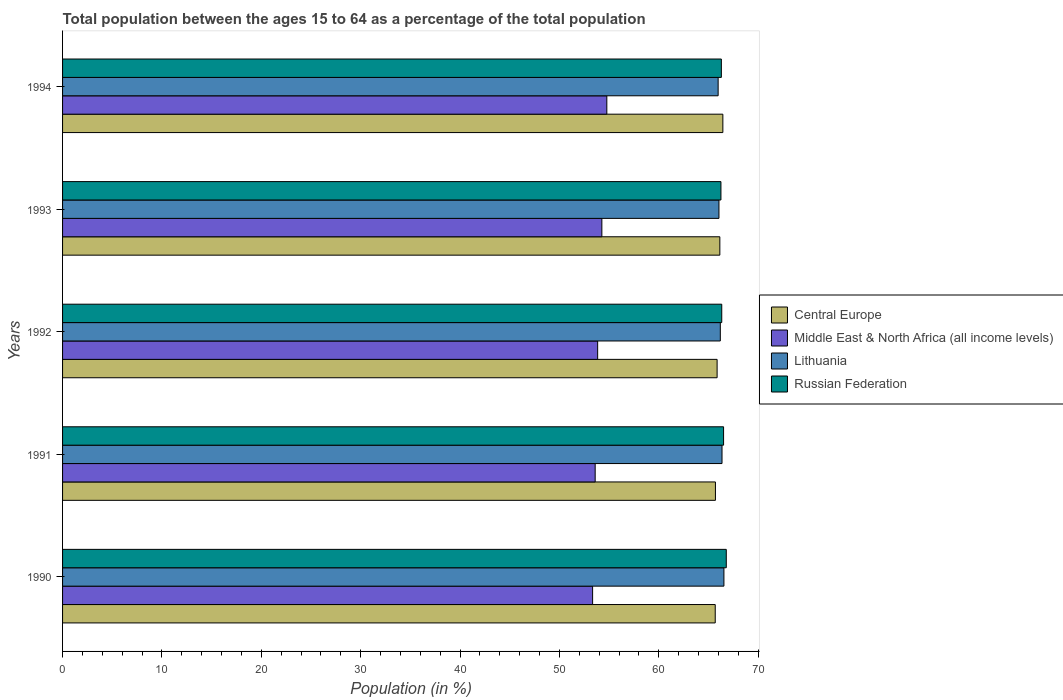How many groups of bars are there?
Give a very brief answer. 5. Are the number of bars per tick equal to the number of legend labels?
Your answer should be very brief. Yes. What is the label of the 2nd group of bars from the top?
Your answer should be compact. 1993. In how many cases, is the number of bars for a given year not equal to the number of legend labels?
Offer a very short reply. 0. What is the percentage of the population ages 15 to 64 in Middle East & North Africa (all income levels) in 1993?
Offer a terse response. 54.27. Across all years, what is the maximum percentage of the population ages 15 to 64 in Russian Federation?
Make the answer very short. 66.79. Across all years, what is the minimum percentage of the population ages 15 to 64 in Russian Federation?
Ensure brevity in your answer.  66.25. In which year was the percentage of the population ages 15 to 64 in Middle East & North Africa (all income levels) minimum?
Make the answer very short. 1990. What is the total percentage of the population ages 15 to 64 in Lithuania in the graph?
Ensure brevity in your answer.  331.14. What is the difference between the percentage of the population ages 15 to 64 in Lithuania in 1990 and that in 1993?
Your answer should be compact. 0.5. What is the difference between the percentage of the population ages 15 to 64 in Lithuania in 1990 and the percentage of the population ages 15 to 64 in Central Europe in 1992?
Your response must be concise. 0.69. What is the average percentage of the population ages 15 to 64 in Lithuania per year?
Keep it short and to the point. 66.23. In the year 1991, what is the difference between the percentage of the population ages 15 to 64 in Central Europe and percentage of the population ages 15 to 64 in Middle East & North Africa (all income levels)?
Your answer should be very brief. 12.1. In how many years, is the percentage of the population ages 15 to 64 in Russian Federation greater than 24 ?
Your answer should be very brief. 5. What is the ratio of the percentage of the population ages 15 to 64 in Middle East & North Africa (all income levels) in 1991 to that in 1993?
Ensure brevity in your answer.  0.99. Is the difference between the percentage of the population ages 15 to 64 in Central Europe in 1991 and 1992 greater than the difference between the percentage of the population ages 15 to 64 in Middle East & North Africa (all income levels) in 1991 and 1992?
Give a very brief answer. Yes. What is the difference between the highest and the second highest percentage of the population ages 15 to 64 in Russian Federation?
Your answer should be very brief. 0.27. What is the difference between the highest and the lowest percentage of the population ages 15 to 64 in Middle East & North Africa (all income levels)?
Your response must be concise. 1.43. Is it the case that in every year, the sum of the percentage of the population ages 15 to 64 in Lithuania and percentage of the population ages 15 to 64 in Russian Federation is greater than the sum of percentage of the population ages 15 to 64 in Central Europe and percentage of the population ages 15 to 64 in Middle East & North Africa (all income levels)?
Provide a short and direct response. Yes. What does the 3rd bar from the top in 1993 represents?
Give a very brief answer. Middle East & North Africa (all income levels). What does the 4th bar from the bottom in 1991 represents?
Your answer should be compact. Russian Federation. Is it the case that in every year, the sum of the percentage of the population ages 15 to 64 in Lithuania and percentage of the population ages 15 to 64 in Russian Federation is greater than the percentage of the population ages 15 to 64 in Central Europe?
Make the answer very short. Yes. How many years are there in the graph?
Provide a short and direct response. 5. What is the difference between two consecutive major ticks on the X-axis?
Your response must be concise. 10. Does the graph contain grids?
Your answer should be very brief. No. Where does the legend appear in the graph?
Your answer should be very brief. Center right. How are the legend labels stacked?
Ensure brevity in your answer.  Vertical. What is the title of the graph?
Offer a very short reply. Total population between the ages 15 to 64 as a percentage of the total population. Does "Jamaica" appear as one of the legend labels in the graph?
Give a very brief answer. No. What is the label or title of the X-axis?
Offer a terse response. Population (in %). What is the label or title of the Y-axis?
Offer a terse response. Years. What is the Population (in %) in Central Europe in 1990?
Offer a very short reply. 65.68. What is the Population (in %) of Middle East & North Africa (all income levels) in 1990?
Ensure brevity in your answer.  53.34. What is the Population (in %) in Lithuania in 1990?
Make the answer very short. 66.56. What is the Population (in %) of Russian Federation in 1990?
Your response must be concise. 66.79. What is the Population (in %) in Central Europe in 1991?
Keep it short and to the point. 65.7. What is the Population (in %) of Middle East & North Africa (all income levels) in 1991?
Make the answer very short. 53.6. What is the Population (in %) in Lithuania in 1991?
Your answer should be very brief. 66.36. What is the Population (in %) of Russian Federation in 1991?
Give a very brief answer. 66.52. What is the Population (in %) of Central Europe in 1992?
Ensure brevity in your answer.  65.87. What is the Population (in %) in Middle East & North Africa (all income levels) in 1992?
Provide a succinct answer. 53.85. What is the Population (in %) in Lithuania in 1992?
Offer a terse response. 66.19. What is the Population (in %) of Russian Federation in 1992?
Offer a very short reply. 66.34. What is the Population (in %) in Central Europe in 1993?
Your answer should be very brief. 66.15. What is the Population (in %) of Middle East & North Africa (all income levels) in 1993?
Offer a very short reply. 54.27. What is the Population (in %) of Lithuania in 1993?
Your answer should be very brief. 66.06. What is the Population (in %) of Russian Federation in 1993?
Your answer should be very brief. 66.25. What is the Population (in %) of Central Europe in 1994?
Provide a short and direct response. 66.45. What is the Population (in %) in Middle East & North Africa (all income levels) in 1994?
Offer a very short reply. 54.77. What is the Population (in %) of Lithuania in 1994?
Your answer should be compact. 65.97. What is the Population (in %) in Russian Federation in 1994?
Your response must be concise. 66.3. Across all years, what is the maximum Population (in %) in Central Europe?
Make the answer very short. 66.45. Across all years, what is the maximum Population (in %) in Middle East & North Africa (all income levels)?
Your answer should be very brief. 54.77. Across all years, what is the maximum Population (in %) of Lithuania?
Make the answer very short. 66.56. Across all years, what is the maximum Population (in %) of Russian Federation?
Your answer should be compact. 66.79. Across all years, what is the minimum Population (in %) in Central Europe?
Your answer should be compact. 65.68. Across all years, what is the minimum Population (in %) of Middle East & North Africa (all income levels)?
Provide a short and direct response. 53.34. Across all years, what is the minimum Population (in %) of Lithuania?
Keep it short and to the point. 65.97. Across all years, what is the minimum Population (in %) of Russian Federation?
Your answer should be compact. 66.25. What is the total Population (in %) of Central Europe in the graph?
Offer a terse response. 329.85. What is the total Population (in %) of Middle East & North Africa (all income levels) in the graph?
Offer a terse response. 269.83. What is the total Population (in %) of Lithuania in the graph?
Provide a succinct answer. 331.14. What is the total Population (in %) in Russian Federation in the graph?
Offer a very short reply. 332.2. What is the difference between the Population (in %) in Central Europe in 1990 and that in 1991?
Offer a terse response. -0.02. What is the difference between the Population (in %) in Middle East & North Africa (all income levels) in 1990 and that in 1991?
Offer a terse response. -0.26. What is the difference between the Population (in %) of Lithuania in 1990 and that in 1991?
Provide a short and direct response. 0.19. What is the difference between the Population (in %) in Russian Federation in 1990 and that in 1991?
Ensure brevity in your answer.  0.27. What is the difference between the Population (in %) of Central Europe in 1990 and that in 1992?
Provide a succinct answer. -0.19. What is the difference between the Population (in %) in Middle East & North Africa (all income levels) in 1990 and that in 1992?
Your response must be concise. -0.51. What is the difference between the Population (in %) in Lithuania in 1990 and that in 1992?
Give a very brief answer. 0.36. What is the difference between the Population (in %) in Russian Federation in 1990 and that in 1992?
Provide a short and direct response. 0.46. What is the difference between the Population (in %) of Central Europe in 1990 and that in 1993?
Offer a very short reply. -0.46. What is the difference between the Population (in %) in Middle East & North Africa (all income levels) in 1990 and that in 1993?
Your answer should be compact. -0.93. What is the difference between the Population (in %) in Lithuania in 1990 and that in 1993?
Offer a very short reply. 0.5. What is the difference between the Population (in %) of Russian Federation in 1990 and that in 1993?
Give a very brief answer. 0.54. What is the difference between the Population (in %) of Central Europe in 1990 and that in 1994?
Provide a short and direct response. -0.77. What is the difference between the Population (in %) of Middle East & North Africa (all income levels) in 1990 and that in 1994?
Keep it short and to the point. -1.43. What is the difference between the Population (in %) in Lithuania in 1990 and that in 1994?
Your response must be concise. 0.58. What is the difference between the Population (in %) of Russian Federation in 1990 and that in 1994?
Keep it short and to the point. 0.49. What is the difference between the Population (in %) of Central Europe in 1991 and that in 1992?
Ensure brevity in your answer.  -0.17. What is the difference between the Population (in %) of Middle East & North Africa (all income levels) in 1991 and that in 1992?
Offer a very short reply. -0.25. What is the difference between the Population (in %) of Lithuania in 1991 and that in 1992?
Offer a terse response. 0.17. What is the difference between the Population (in %) of Russian Federation in 1991 and that in 1992?
Offer a very short reply. 0.18. What is the difference between the Population (in %) in Central Europe in 1991 and that in 1993?
Provide a short and direct response. -0.44. What is the difference between the Population (in %) of Middle East & North Africa (all income levels) in 1991 and that in 1993?
Keep it short and to the point. -0.67. What is the difference between the Population (in %) of Lithuania in 1991 and that in 1993?
Your response must be concise. 0.31. What is the difference between the Population (in %) in Russian Federation in 1991 and that in 1993?
Provide a succinct answer. 0.27. What is the difference between the Population (in %) of Central Europe in 1991 and that in 1994?
Ensure brevity in your answer.  -0.75. What is the difference between the Population (in %) of Middle East & North Africa (all income levels) in 1991 and that in 1994?
Your answer should be very brief. -1.17. What is the difference between the Population (in %) of Lithuania in 1991 and that in 1994?
Provide a short and direct response. 0.39. What is the difference between the Population (in %) in Russian Federation in 1991 and that in 1994?
Make the answer very short. 0.22. What is the difference between the Population (in %) in Central Europe in 1992 and that in 1993?
Give a very brief answer. -0.28. What is the difference between the Population (in %) in Middle East & North Africa (all income levels) in 1992 and that in 1993?
Your answer should be very brief. -0.42. What is the difference between the Population (in %) of Lithuania in 1992 and that in 1993?
Offer a terse response. 0.14. What is the difference between the Population (in %) of Russian Federation in 1992 and that in 1993?
Offer a very short reply. 0.08. What is the difference between the Population (in %) in Central Europe in 1992 and that in 1994?
Make the answer very short. -0.58. What is the difference between the Population (in %) in Middle East & North Africa (all income levels) in 1992 and that in 1994?
Offer a terse response. -0.92. What is the difference between the Population (in %) in Lithuania in 1992 and that in 1994?
Provide a succinct answer. 0.22. What is the difference between the Population (in %) in Russian Federation in 1992 and that in 1994?
Provide a short and direct response. 0.04. What is the difference between the Population (in %) of Central Europe in 1993 and that in 1994?
Make the answer very short. -0.3. What is the difference between the Population (in %) of Middle East & North Africa (all income levels) in 1993 and that in 1994?
Provide a short and direct response. -0.5. What is the difference between the Population (in %) in Lithuania in 1993 and that in 1994?
Offer a very short reply. 0.08. What is the difference between the Population (in %) of Russian Federation in 1993 and that in 1994?
Ensure brevity in your answer.  -0.04. What is the difference between the Population (in %) in Central Europe in 1990 and the Population (in %) in Middle East & North Africa (all income levels) in 1991?
Your answer should be compact. 12.08. What is the difference between the Population (in %) of Central Europe in 1990 and the Population (in %) of Lithuania in 1991?
Your answer should be very brief. -0.68. What is the difference between the Population (in %) in Central Europe in 1990 and the Population (in %) in Russian Federation in 1991?
Ensure brevity in your answer.  -0.84. What is the difference between the Population (in %) in Middle East & North Africa (all income levels) in 1990 and the Population (in %) in Lithuania in 1991?
Make the answer very short. -13.02. What is the difference between the Population (in %) in Middle East & North Africa (all income levels) in 1990 and the Population (in %) in Russian Federation in 1991?
Your answer should be very brief. -13.18. What is the difference between the Population (in %) in Lithuania in 1990 and the Population (in %) in Russian Federation in 1991?
Provide a succinct answer. 0.03. What is the difference between the Population (in %) of Central Europe in 1990 and the Population (in %) of Middle East & North Africa (all income levels) in 1992?
Your answer should be very brief. 11.83. What is the difference between the Population (in %) in Central Europe in 1990 and the Population (in %) in Lithuania in 1992?
Your response must be concise. -0.51. What is the difference between the Population (in %) of Central Europe in 1990 and the Population (in %) of Russian Federation in 1992?
Give a very brief answer. -0.66. What is the difference between the Population (in %) in Middle East & North Africa (all income levels) in 1990 and the Population (in %) in Lithuania in 1992?
Your answer should be very brief. -12.85. What is the difference between the Population (in %) of Middle East & North Africa (all income levels) in 1990 and the Population (in %) of Russian Federation in 1992?
Your response must be concise. -13. What is the difference between the Population (in %) in Lithuania in 1990 and the Population (in %) in Russian Federation in 1992?
Make the answer very short. 0.22. What is the difference between the Population (in %) of Central Europe in 1990 and the Population (in %) of Middle East & North Africa (all income levels) in 1993?
Keep it short and to the point. 11.41. What is the difference between the Population (in %) in Central Europe in 1990 and the Population (in %) in Lithuania in 1993?
Provide a succinct answer. -0.37. What is the difference between the Population (in %) in Central Europe in 1990 and the Population (in %) in Russian Federation in 1993?
Make the answer very short. -0.57. What is the difference between the Population (in %) of Middle East & North Africa (all income levels) in 1990 and the Population (in %) of Lithuania in 1993?
Your answer should be very brief. -12.72. What is the difference between the Population (in %) of Middle East & North Africa (all income levels) in 1990 and the Population (in %) of Russian Federation in 1993?
Offer a terse response. -12.91. What is the difference between the Population (in %) in Lithuania in 1990 and the Population (in %) in Russian Federation in 1993?
Your response must be concise. 0.3. What is the difference between the Population (in %) in Central Europe in 1990 and the Population (in %) in Middle East & North Africa (all income levels) in 1994?
Provide a succinct answer. 10.91. What is the difference between the Population (in %) of Central Europe in 1990 and the Population (in %) of Lithuania in 1994?
Your answer should be very brief. -0.29. What is the difference between the Population (in %) in Central Europe in 1990 and the Population (in %) in Russian Federation in 1994?
Offer a very short reply. -0.62. What is the difference between the Population (in %) of Middle East & North Africa (all income levels) in 1990 and the Population (in %) of Lithuania in 1994?
Offer a very short reply. -12.63. What is the difference between the Population (in %) in Middle East & North Africa (all income levels) in 1990 and the Population (in %) in Russian Federation in 1994?
Provide a succinct answer. -12.96. What is the difference between the Population (in %) of Lithuania in 1990 and the Population (in %) of Russian Federation in 1994?
Provide a succinct answer. 0.26. What is the difference between the Population (in %) of Central Europe in 1991 and the Population (in %) of Middle East & North Africa (all income levels) in 1992?
Offer a very short reply. 11.85. What is the difference between the Population (in %) of Central Europe in 1991 and the Population (in %) of Lithuania in 1992?
Your answer should be very brief. -0.49. What is the difference between the Population (in %) in Central Europe in 1991 and the Population (in %) in Russian Federation in 1992?
Provide a short and direct response. -0.64. What is the difference between the Population (in %) in Middle East & North Africa (all income levels) in 1991 and the Population (in %) in Lithuania in 1992?
Your answer should be compact. -12.59. What is the difference between the Population (in %) in Middle East & North Africa (all income levels) in 1991 and the Population (in %) in Russian Federation in 1992?
Your answer should be compact. -12.74. What is the difference between the Population (in %) of Lithuania in 1991 and the Population (in %) of Russian Federation in 1992?
Ensure brevity in your answer.  0.03. What is the difference between the Population (in %) of Central Europe in 1991 and the Population (in %) of Middle East & North Africa (all income levels) in 1993?
Make the answer very short. 11.43. What is the difference between the Population (in %) of Central Europe in 1991 and the Population (in %) of Lithuania in 1993?
Your response must be concise. -0.35. What is the difference between the Population (in %) in Central Europe in 1991 and the Population (in %) in Russian Federation in 1993?
Your answer should be compact. -0.55. What is the difference between the Population (in %) of Middle East & North Africa (all income levels) in 1991 and the Population (in %) of Lithuania in 1993?
Keep it short and to the point. -12.46. What is the difference between the Population (in %) in Middle East & North Africa (all income levels) in 1991 and the Population (in %) in Russian Federation in 1993?
Offer a terse response. -12.66. What is the difference between the Population (in %) of Lithuania in 1991 and the Population (in %) of Russian Federation in 1993?
Keep it short and to the point. 0.11. What is the difference between the Population (in %) in Central Europe in 1991 and the Population (in %) in Middle East & North Africa (all income levels) in 1994?
Give a very brief answer. 10.93. What is the difference between the Population (in %) in Central Europe in 1991 and the Population (in %) in Lithuania in 1994?
Offer a very short reply. -0.27. What is the difference between the Population (in %) of Central Europe in 1991 and the Population (in %) of Russian Federation in 1994?
Offer a very short reply. -0.6. What is the difference between the Population (in %) in Middle East & North Africa (all income levels) in 1991 and the Population (in %) in Lithuania in 1994?
Make the answer very short. -12.38. What is the difference between the Population (in %) in Middle East & North Africa (all income levels) in 1991 and the Population (in %) in Russian Federation in 1994?
Provide a short and direct response. -12.7. What is the difference between the Population (in %) in Lithuania in 1991 and the Population (in %) in Russian Federation in 1994?
Your answer should be compact. 0.07. What is the difference between the Population (in %) in Central Europe in 1992 and the Population (in %) in Middle East & North Africa (all income levels) in 1993?
Provide a short and direct response. 11.6. What is the difference between the Population (in %) of Central Europe in 1992 and the Population (in %) of Lithuania in 1993?
Your answer should be very brief. -0.19. What is the difference between the Population (in %) of Central Europe in 1992 and the Population (in %) of Russian Federation in 1993?
Your answer should be compact. -0.38. What is the difference between the Population (in %) in Middle East & North Africa (all income levels) in 1992 and the Population (in %) in Lithuania in 1993?
Keep it short and to the point. -12.21. What is the difference between the Population (in %) of Middle East & North Africa (all income levels) in 1992 and the Population (in %) of Russian Federation in 1993?
Give a very brief answer. -12.41. What is the difference between the Population (in %) of Lithuania in 1992 and the Population (in %) of Russian Federation in 1993?
Ensure brevity in your answer.  -0.06. What is the difference between the Population (in %) in Central Europe in 1992 and the Population (in %) in Middle East & North Africa (all income levels) in 1994?
Give a very brief answer. 11.1. What is the difference between the Population (in %) in Central Europe in 1992 and the Population (in %) in Lithuania in 1994?
Make the answer very short. -0.1. What is the difference between the Population (in %) in Central Europe in 1992 and the Population (in %) in Russian Federation in 1994?
Make the answer very short. -0.43. What is the difference between the Population (in %) of Middle East & North Africa (all income levels) in 1992 and the Population (in %) of Lithuania in 1994?
Your response must be concise. -12.12. What is the difference between the Population (in %) in Middle East & North Africa (all income levels) in 1992 and the Population (in %) in Russian Federation in 1994?
Provide a succinct answer. -12.45. What is the difference between the Population (in %) in Lithuania in 1992 and the Population (in %) in Russian Federation in 1994?
Ensure brevity in your answer.  -0.11. What is the difference between the Population (in %) in Central Europe in 1993 and the Population (in %) in Middle East & North Africa (all income levels) in 1994?
Offer a terse response. 11.37. What is the difference between the Population (in %) in Central Europe in 1993 and the Population (in %) in Lithuania in 1994?
Your answer should be compact. 0.17. What is the difference between the Population (in %) of Central Europe in 1993 and the Population (in %) of Russian Federation in 1994?
Make the answer very short. -0.15. What is the difference between the Population (in %) in Middle East & North Africa (all income levels) in 1993 and the Population (in %) in Lithuania in 1994?
Provide a short and direct response. -11.7. What is the difference between the Population (in %) of Middle East & North Africa (all income levels) in 1993 and the Population (in %) of Russian Federation in 1994?
Provide a succinct answer. -12.03. What is the difference between the Population (in %) in Lithuania in 1993 and the Population (in %) in Russian Federation in 1994?
Provide a succinct answer. -0.24. What is the average Population (in %) of Central Europe per year?
Your answer should be compact. 65.97. What is the average Population (in %) in Middle East & North Africa (all income levels) per year?
Keep it short and to the point. 53.97. What is the average Population (in %) of Lithuania per year?
Your answer should be very brief. 66.23. What is the average Population (in %) of Russian Federation per year?
Give a very brief answer. 66.44. In the year 1990, what is the difference between the Population (in %) in Central Europe and Population (in %) in Middle East & North Africa (all income levels)?
Keep it short and to the point. 12.34. In the year 1990, what is the difference between the Population (in %) of Central Europe and Population (in %) of Lithuania?
Provide a succinct answer. -0.87. In the year 1990, what is the difference between the Population (in %) of Central Europe and Population (in %) of Russian Federation?
Your response must be concise. -1.11. In the year 1990, what is the difference between the Population (in %) in Middle East & North Africa (all income levels) and Population (in %) in Lithuania?
Provide a short and direct response. -13.22. In the year 1990, what is the difference between the Population (in %) of Middle East & North Africa (all income levels) and Population (in %) of Russian Federation?
Give a very brief answer. -13.45. In the year 1990, what is the difference between the Population (in %) of Lithuania and Population (in %) of Russian Federation?
Ensure brevity in your answer.  -0.24. In the year 1991, what is the difference between the Population (in %) in Central Europe and Population (in %) in Middle East & North Africa (all income levels)?
Give a very brief answer. 12.1. In the year 1991, what is the difference between the Population (in %) in Central Europe and Population (in %) in Lithuania?
Provide a short and direct response. -0.66. In the year 1991, what is the difference between the Population (in %) in Central Europe and Population (in %) in Russian Federation?
Offer a terse response. -0.82. In the year 1991, what is the difference between the Population (in %) of Middle East & North Africa (all income levels) and Population (in %) of Lithuania?
Give a very brief answer. -12.77. In the year 1991, what is the difference between the Population (in %) of Middle East & North Africa (all income levels) and Population (in %) of Russian Federation?
Your answer should be very brief. -12.92. In the year 1991, what is the difference between the Population (in %) in Lithuania and Population (in %) in Russian Federation?
Your response must be concise. -0.16. In the year 1992, what is the difference between the Population (in %) in Central Europe and Population (in %) in Middle East & North Africa (all income levels)?
Offer a very short reply. 12.02. In the year 1992, what is the difference between the Population (in %) in Central Europe and Population (in %) in Lithuania?
Make the answer very short. -0.32. In the year 1992, what is the difference between the Population (in %) in Central Europe and Population (in %) in Russian Federation?
Make the answer very short. -0.47. In the year 1992, what is the difference between the Population (in %) in Middle East & North Africa (all income levels) and Population (in %) in Lithuania?
Give a very brief answer. -12.34. In the year 1992, what is the difference between the Population (in %) in Middle East & North Africa (all income levels) and Population (in %) in Russian Federation?
Your answer should be compact. -12.49. In the year 1992, what is the difference between the Population (in %) in Lithuania and Population (in %) in Russian Federation?
Offer a very short reply. -0.15. In the year 1993, what is the difference between the Population (in %) in Central Europe and Population (in %) in Middle East & North Africa (all income levels)?
Make the answer very short. 11.87. In the year 1993, what is the difference between the Population (in %) in Central Europe and Population (in %) in Lithuania?
Your answer should be compact. 0.09. In the year 1993, what is the difference between the Population (in %) of Central Europe and Population (in %) of Russian Federation?
Keep it short and to the point. -0.11. In the year 1993, what is the difference between the Population (in %) in Middle East & North Africa (all income levels) and Population (in %) in Lithuania?
Ensure brevity in your answer.  -11.78. In the year 1993, what is the difference between the Population (in %) in Middle East & North Africa (all income levels) and Population (in %) in Russian Federation?
Ensure brevity in your answer.  -11.98. In the year 1993, what is the difference between the Population (in %) in Lithuania and Population (in %) in Russian Federation?
Your answer should be very brief. -0.2. In the year 1994, what is the difference between the Population (in %) in Central Europe and Population (in %) in Middle East & North Africa (all income levels)?
Provide a short and direct response. 11.68. In the year 1994, what is the difference between the Population (in %) in Central Europe and Population (in %) in Lithuania?
Your answer should be very brief. 0.48. In the year 1994, what is the difference between the Population (in %) in Central Europe and Population (in %) in Russian Federation?
Offer a very short reply. 0.15. In the year 1994, what is the difference between the Population (in %) of Middle East & North Africa (all income levels) and Population (in %) of Lithuania?
Ensure brevity in your answer.  -11.2. In the year 1994, what is the difference between the Population (in %) in Middle East & North Africa (all income levels) and Population (in %) in Russian Federation?
Provide a succinct answer. -11.53. In the year 1994, what is the difference between the Population (in %) in Lithuania and Population (in %) in Russian Federation?
Your response must be concise. -0.32. What is the ratio of the Population (in %) in Lithuania in 1990 to that in 1991?
Provide a short and direct response. 1. What is the ratio of the Population (in %) of Russian Federation in 1990 to that in 1991?
Offer a very short reply. 1. What is the ratio of the Population (in %) of Central Europe in 1990 to that in 1992?
Ensure brevity in your answer.  1. What is the ratio of the Population (in %) in Middle East & North Africa (all income levels) in 1990 to that in 1992?
Provide a short and direct response. 0.99. What is the ratio of the Population (in %) in Lithuania in 1990 to that in 1992?
Your response must be concise. 1.01. What is the ratio of the Population (in %) of Russian Federation in 1990 to that in 1992?
Your answer should be very brief. 1.01. What is the ratio of the Population (in %) of Middle East & North Africa (all income levels) in 1990 to that in 1993?
Give a very brief answer. 0.98. What is the ratio of the Population (in %) of Lithuania in 1990 to that in 1993?
Offer a terse response. 1.01. What is the ratio of the Population (in %) in Central Europe in 1990 to that in 1994?
Your answer should be compact. 0.99. What is the ratio of the Population (in %) of Middle East & North Africa (all income levels) in 1990 to that in 1994?
Your response must be concise. 0.97. What is the ratio of the Population (in %) in Lithuania in 1990 to that in 1994?
Give a very brief answer. 1.01. What is the ratio of the Population (in %) in Russian Federation in 1990 to that in 1994?
Offer a very short reply. 1.01. What is the ratio of the Population (in %) in Central Europe in 1991 to that in 1992?
Offer a very short reply. 1. What is the ratio of the Population (in %) in Lithuania in 1991 to that in 1992?
Your response must be concise. 1. What is the ratio of the Population (in %) of Russian Federation in 1991 to that in 1992?
Give a very brief answer. 1. What is the ratio of the Population (in %) in Central Europe in 1991 to that in 1993?
Give a very brief answer. 0.99. What is the ratio of the Population (in %) in Middle East & North Africa (all income levels) in 1991 to that in 1993?
Give a very brief answer. 0.99. What is the ratio of the Population (in %) of Russian Federation in 1991 to that in 1993?
Provide a succinct answer. 1. What is the ratio of the Population (in %) of Central Europe in 1991 to that in 1994?
Ensure brevity in your answer.  0.99. What is the ratio of the Population (in %) of Middle East & North Africa (all income levels) in 1991 to that in 1994?
Your answer should be very brief. 0.98. What is the ratio of the Population (in %) in Lithuania in 1991 to that in 1994?
Ensure brevity in your answer.  1.01. What is the ratio of the Population (in %) of Russian Federation in 1991 to that in 1994?
Make the answer very short. 1. What is the ratio of the Population (in %) of Middle East & North Africa (all income levels) in 1992 to that in 1994?
Your answer should be compact. 0.98. What is the ratio of the Population (in %) of Lithuania in 1992 to that in 1994?
Provide a short and direct response. 1. What is the ratio of the Population (in %) in Russian Federation in 1992 to that in 1994?
Provide a succinct answer. 1. What is the ratio of the Population (in %) in Middle East & North Africa (all income levels) in 1993 to that in 1994?
Your answer should be compact. 0.99. What is the ratio of the Population (in %) in Russian Federation in 1993 to that in 1994?
Offer a terse response. 1. What is the difference between the highest and the second highest Population (in %) in Central Europe?
Offer a terse response. 0.3. What is the difference between the highest and the second highest Population (in %) in Middle East & North Africa (all income levels)?
Offer a very short reply. 0.5. What is the difference between the highest and the second highest Population (in %) of Lithuania?
Your answer should be very brief. 0.19. What is the difference between the highest and the second highest Population (in %) of Russian Federation?
Provide a short and direct response. 0.27. What is the difference between the highest and the lowest Population (in %) of Central Europe?
Make the answer very short. 0.77. What is the difference between the highest and the lowest Population (in %) in Middle East & North Africa (all income levels)?
Your response must be concise. 1.43. What is the difference between the highest and the lowest Population (in %) in Lithuania?
Offer a very short reply. 0.58. What is the difference between the highest and the lowest Population (in %) of Russian Federation?
Provide a short and direct response. 0.54. 